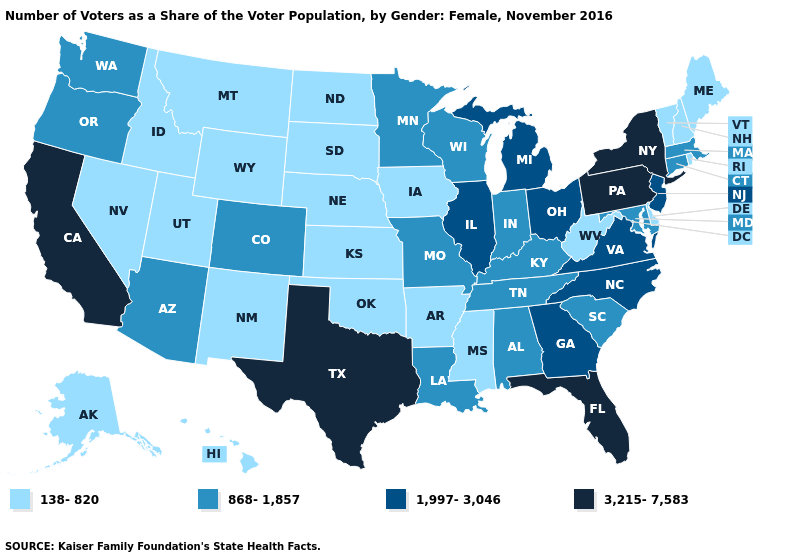Name the states that have a value in the range 138-820?
Concise answer only. Alaska, Arkansas, Delaware, Hawaii, Idaho, Iowa, Kansas, Maine, Mississippi, Montana, Nebraska, Nevada, New Hampshire, New Mexico, North Dakota, Oklahoma, Rhode Island, South Dakota, Utah, Vermont, West Virginia, Wyoming. Name the states that have a value in the range 1,997-3,046?
Quick response, please. Georgia, Illinois, Michigan, New Jersey, North Carolina, Ohio, Virginia. Does New York have the highest value in the Northeast?
Short answer required. Yes. Does the map have missing data?
Answer briefly. No. Which states have the highest value in the USA?
Write a very short answer. California, Florida, New York, Pennsylvania, Texas. What is the highest value in the West ?
Keep it brief. 3,215-7,583. Does Arizona have a lower value than Michigan?
Short answer required. Yes. What is the highest value in states that border Iowa?
Short answer required. 1,997-3,046. Among the states that border Colorado , which have the highest value?
Quick response, please. Arizona. What is the highest value in the West ?
Keep it brief. 3,215-7,583. What is the highest value in the Northeast ?
Answer briefly. 3,215-7,583. Does Oregon have the same value as West Virginia?
Give a very brief answer. No. What is the lowest value in the USA?
Be succinct. 138-820. Does the first symbol in the legend represent the smallest category?
Write a very short answer. Yes. Does the first symbol in the legend represent the smallest category?
Give a very brief answer. Yes. 